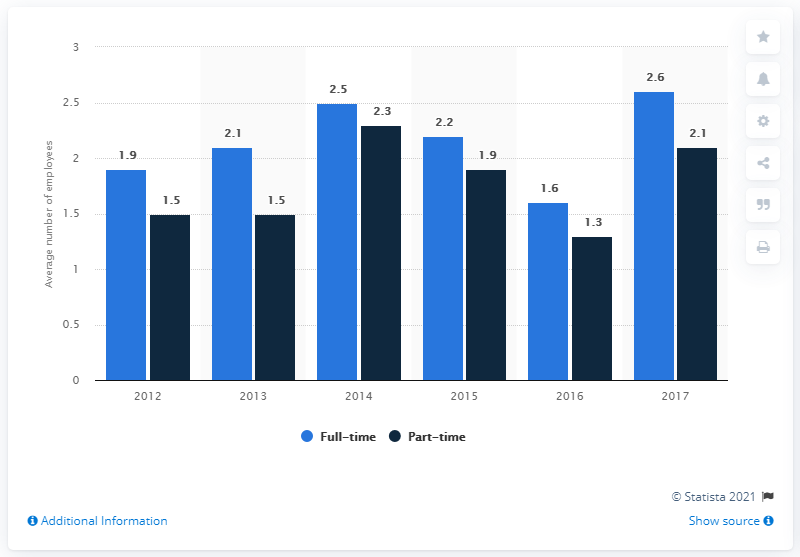Indicate a few pertinent items in this graphic. According to data from 2016, the average number of full-time salon employees in the UK was 1.6. 